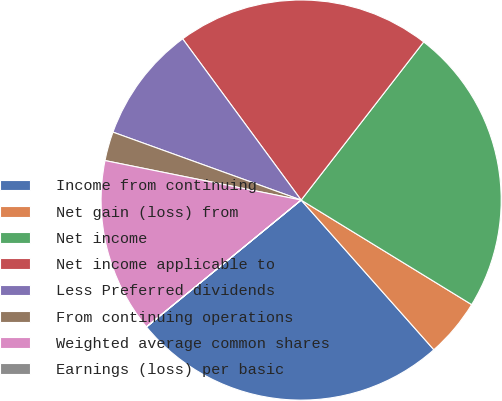<chart> <loc_0><loc_0><loc_500><loc_500><pie_chart><fcel>Income from continuing<fcel>Net gain (loss) from<fcel>Net income<fcel>Net income applicable to<fcel>Less Preferred dividends<fcel>From continuing operations<fcel>Weighted average common shares<fcel>Earnings (loss) per basic<nl><fcel>25.61%<fcel>4.7%<fcel>23.26%<fcel>20.58%<fcel>9.4%<fcel>2.35%<fcel>14.09%<fcel>0.01%<nl></chart> 